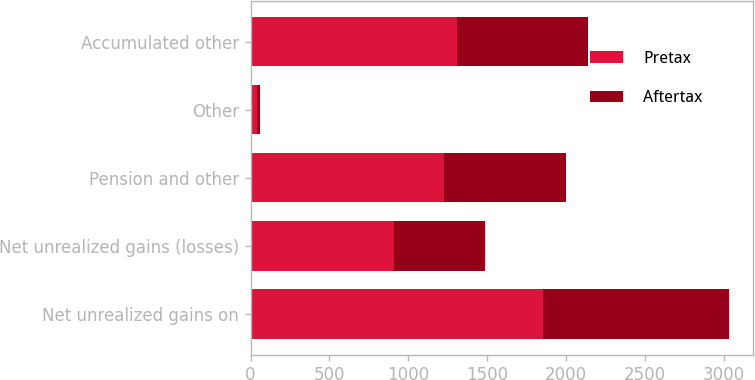Convert chart to OTSL. <chart><loc_0><loc_0><loc_500><loc_500><stacked_bar_chart><ecel><fcel>Net unrealized gains on<fcel>Net unrealized gains (losses)<fcel>Pension and other<fcel>Other<fcel>Accumulated other<nl><fcel>Pretax<fcel>1858<fcel>911<fcel>1226<fcel>41<fcel>1307<nl><fcel>Aftertax<fcel>1177<fcel>578<fcel>777<fcel>21<fcel>834<nl></chart> 